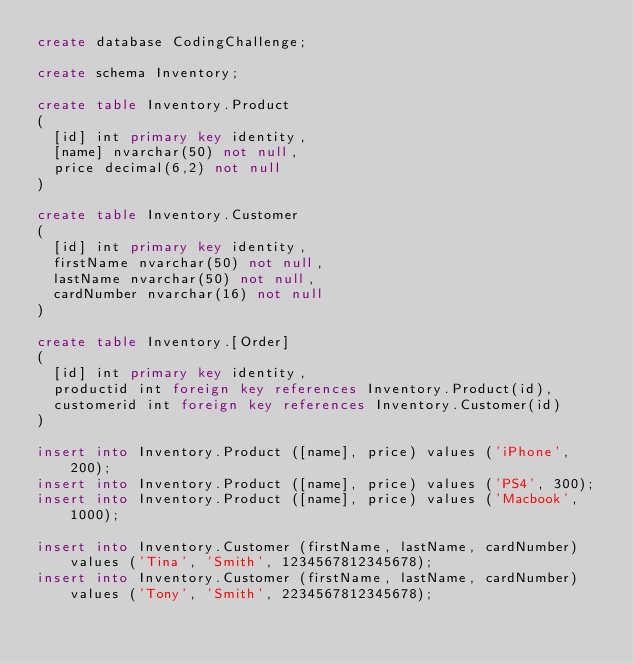Convert code to text. <code><loc_0><loc_0><loc_500><loc_500><_SQL_>create database CodingChallenge;

create schema Inventory;

create table Inventory.Product
(
	[id] int primary key identity,
	[name] nvarchar(50) not null,
	price decimal(6,2) not null
)

create table Inventory.Customer
(
	[id] int primary key identity,
	firstName nvarchar(50) not null,
	lastName nvarchar(50) not null,
	cardNumber nvarchar(16) not null
)

create table Inventory.[Order]
(
	[id] int primary key identity,
	productid int foreign key references Inventory.Product(id),
	customerid int foreign key references Inventory.Customer(id)
)

insert into Inventory.Product ([name], price) values ('iPhone', 200);
insert into Inventory.Product ([name], price) values ('PS4', 300);
insert into Inventory.Product ([name], price) values ('Macbook', 1000);

insert into Inventory.Customer (firstName, lastName, cardNumber) values ('Tina', 'Smith', 1234567812345678);
insert into Inventory.Customer (firstName, lastName, cardNumber) values ('Tony', 'Smith', 2234567812345678);</code> 